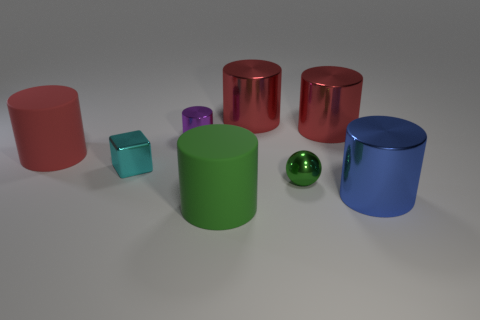Subtract all blue cylinders. How many cylinders are left? 5 Add 1 tiny cylinders. How many objects exist? 9 Subtract all blue cylinders. How many cylinders are left? 5 Subtract all green blocks. How many red cylinders are left? 3 Subtract all spheres. How many objects are left? 7 Subtract 1 balls. How many balls are left? 0 Subtract all yellow cubes. Subtract all blue cylinders. How many cubes are left? 1 Subtract all small purple cylinders. Subtract all purple shiny things. How many objects are left? 6 Add 2 big green rubber objects. How many big green rubber objects are left? 3 Add 8 tiny yellow matte cylinders. How many tiny yellow matte cylinders exist? 8 